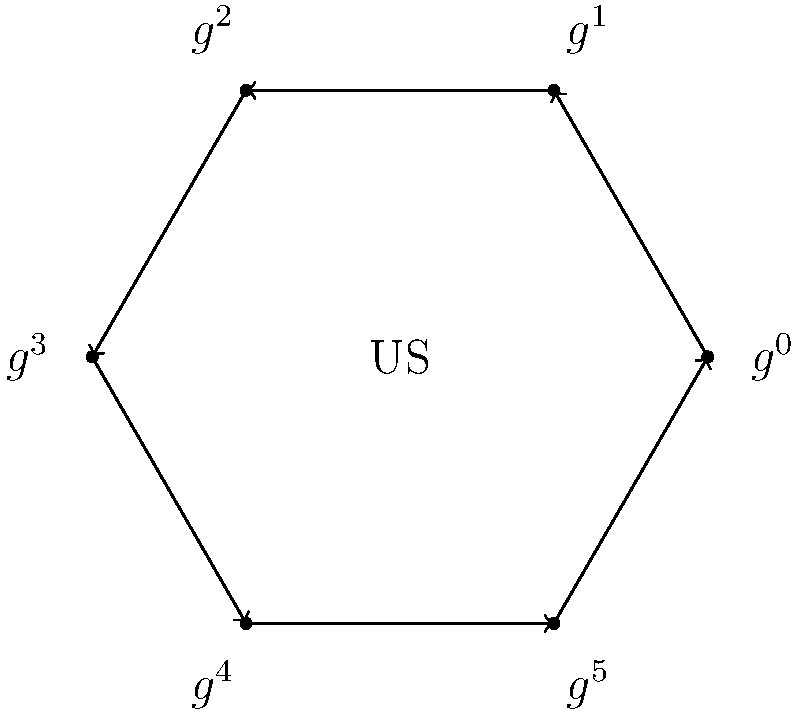Consider the Cayley diagram of a cyclic group $C_6$ representing trade cycles between African countries and the US. If $g$ represents a trade agreement that shifts the focus to the next African country in the cycle, what element of the group represents returning to the original trade focus after engaging with three different African countries? To solve this problem, we need to follow these steps:

1. Understand the Cayley diagram:
   - The diagram represents a cyclic group $C_6$ with 6 elements.
   - Each element $g^i$ represents a state of trade focus with a specific African country.
   - The arrow represents the action of $g$, which shifts the focus to the next country.

2. Interpret the question:
   - We start at an arbitrary position (let's say $g^0$).
   - We need to apply the operation $g$ three times to represent engaging with three different African countries.

3. Calculate the result:
   - Starting from $g^0$:
     - First application of $g$: $g^0 \cdot g = g^1$
     - Second application of $g$: $g^1 \cdot g = g^2$
     - Third application of $g$: $g^2 \cdot g = g^3$

4. Interpret the result:
   - After three applications of $g$, we arrive at $g^3$.
   - $g^3$ represents half a rotation around the cycle.
   - In group theory, $g^3$ is the element that, when applied twice, returns to the identity (original position).

Therefore, $g^3$ represents returning to the original trade focus after engaging with three different African countries.
Answer: $g^3$ 